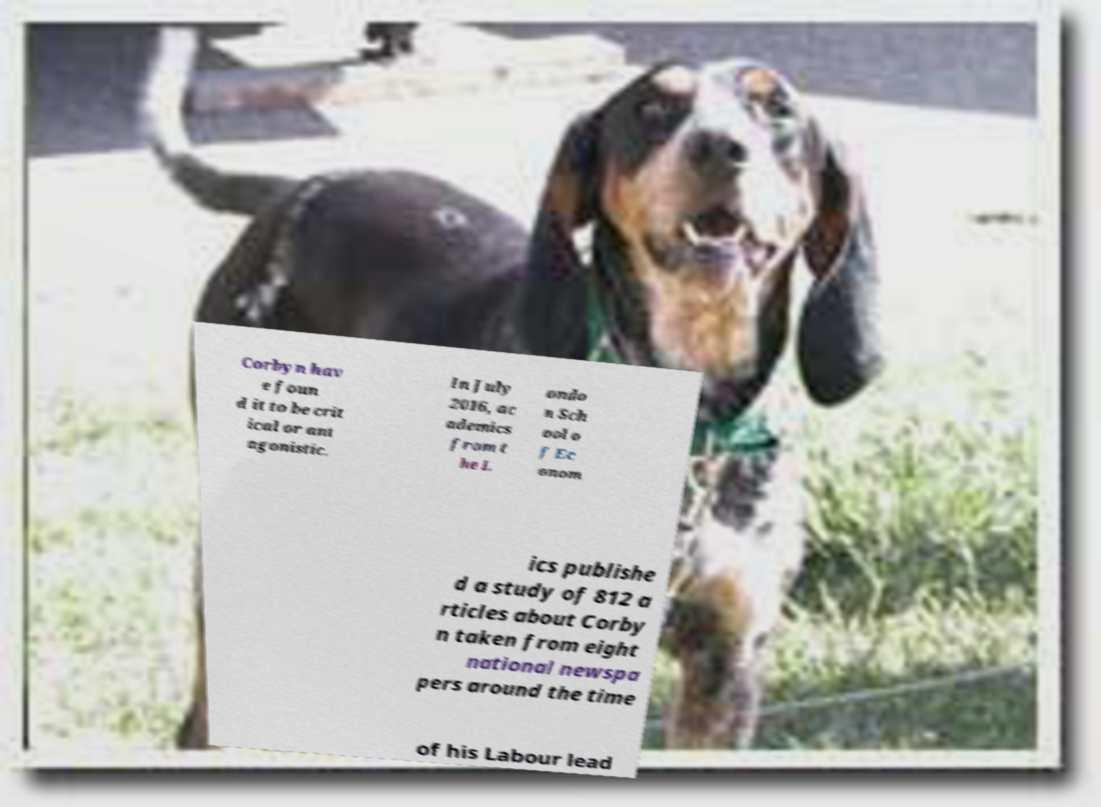Can you accurately transcribe the text from the provided image for me? Corbyn hav e foun d it to be crit ical or ant agonistic. In July 2016, ac ademics from t he L ondo n Sch ool o f Ec onom ics publishe d a study of 812 a rticles about Corby n taken from eight national newspa pers around the time of his Labour lead 